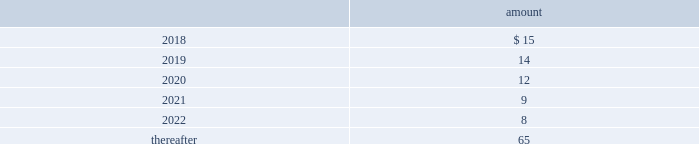Deposits 2014deposits include escrow funds and certain other deposits held in trust .
The company includes cash deposits in other current assets .
Deferred compensation obligations 2014the company 2019s deferred compensation plans allow participants to defer certain cash compensation into notional investment accounts .
The company includes such plans in other long-term liabilities .
The value of the company 2019s deferred compensation obligations is based on the market value of the participants 2019 notional investment accounts .
The notional investments are comprised primarily of mutual funds , which are based on observable market prices .
Mark-to-market derivative asset and liability 2014the company utilizes fixed-to-floating interest-rate swaps , typically designated as fair-value hedges , to achieve a targeted level of variable-rate debt as a percentage of total debt .
The company also employs derivative financial instruments in the form of variable-to-fixed interest rate swaps and forward starting interest rate swaps , classified as economic hedges and cash flow hedges , respectively , in order to fix the interest cost on existing or forecasted debt .
The company uses a calculation of future cash inflows and estimated future outflows , which are discounted , to determine the current fair value .
Additional inputs to the present value calculation include the contract terms , counterparty credit risk , interest rates and market volatility .
Other investments 2014other investments primarily represent money market funds used for active employee benefits .
The company includes other investments in other current assets .
Note 18 : leases the company has entered into operating leases involving certain facilities and equipment .
Rental expenses under operating leases were $ 29 million , $ 24 million and $ 21 million for the years ended december 31 , 2017 , 2016 and 2015 , respectively .
The operating leases for facilities will expire over the next 25 years and the operating leases for equipment will expire over the next 5 years .
Certain operating leases have renewal options ranging from one to five years .
The minimum annual future rental commitment under operating leases that have initial or remaining non-cancelable lease terms over the next 5 years and thereafter are as follows: .
The company has a series of agreements with various public entities ( the 201cpartners 201d ) to establish certain joint ventures , commonly referred to as 201cpublic-private partnerships . 201d under the public-private partnerships , the company constructed utility plant , financed by the company and the partners constructed utility plant ( connected to the company 2019s property ) , financed by the partners .
The company agreed to transfer and convey some of its real and personal property to the partners in exchange for an equal principal amount of industrial development bonds ( 201cidbs 201d ) , issued by the partners under a state industrial development bond and commercial development act .
The company leased back the total facilities , including portions funded by both the company and the partners , under leases for a period of 40 years .
The leases related to the portion of the facilities funded by the company have required payments from the company to the partners that approximate the payments required by the terms of the idbs from the partners to the company ( as the holder of the idbs ) .
As the ownership of the portion of the facilities constructed by the .
What percentage of minimum annual future rental commitment under operating leases that have initial or remaining non-cancelable lease terms is payable in 2022? 
Rationale: from here you need to take the amount payable in 2018 , or $ 15 , and divide by the total or 123 to get 12.2% ( 15/123 = 12.2% )
Computations: (((12 + 9) + (15 + 14)) + (8 + 65))
Answer: 123.0. 